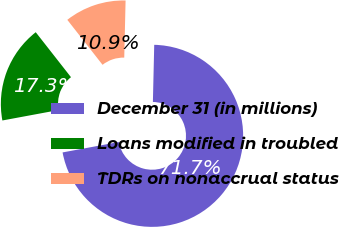<chart> <loc_0><loc_0><loc_500><loc_500><pie_chart><fcel>December 31 (in millions)<fcel>Loans modified in troubled<fcel>TDRs on nonaccrual status<nl><fcel>71.71%<fcel>17.34%<fcel>10.95%<nl></chart> 